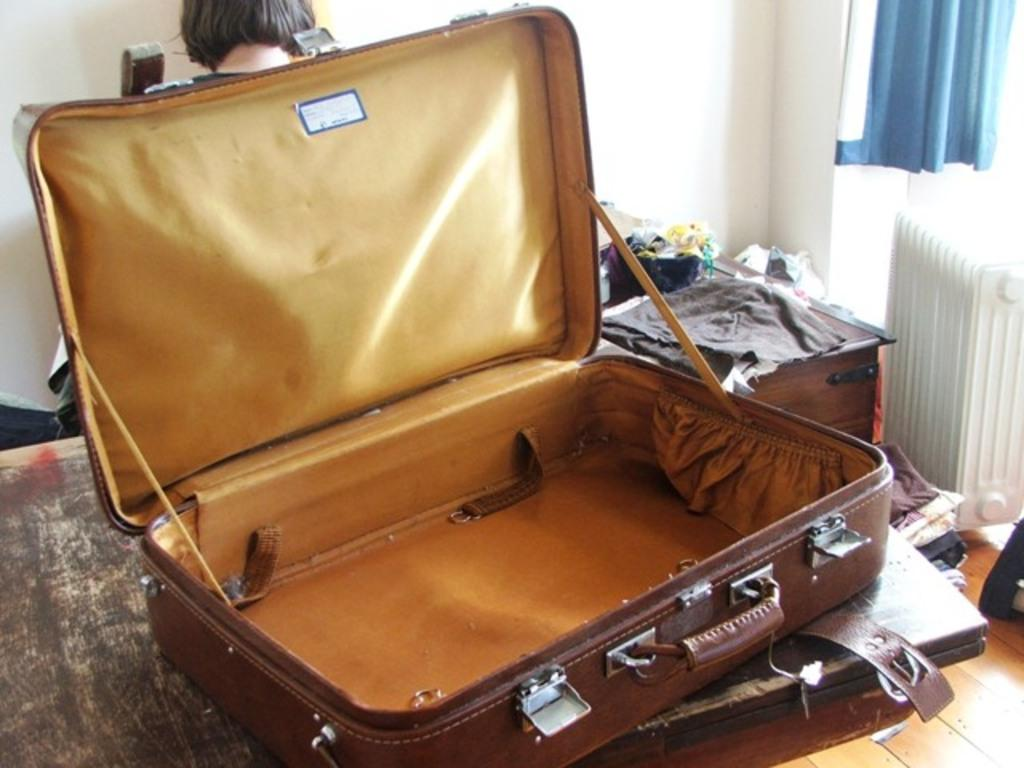What object is present in the image that can be used for carrying items? There is a bag in the image that can be used for carrying items. What is depicted on the bag? There is a woman on the back side of the bag. What else can be seen in the image besides the bag? There are clothes in the image. What type of window treatment is visible in the image? There is a blue color curtain in the image. What type of grape is being used to cook on the stove in the image? There is no grape or stove present in the image. How many carts are visible in the image? There are no carts visible in the image. 